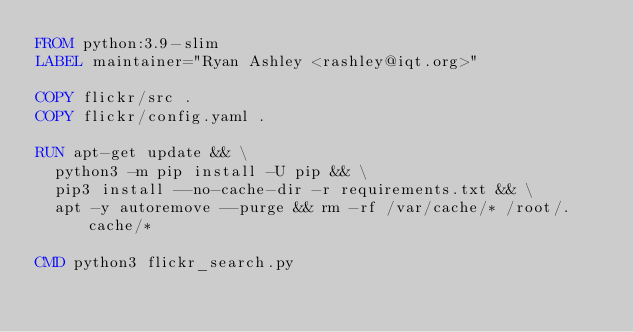<code> <loc_0><loc_0><loc_500><loc_500><_Dockerfile_>FROM python:3.9-slim
LABEL maintainer="Ryan Ashley <rashley@iqt.org>"

COPY flickr/src .
COPY flickr/config.yaml .

RUN apt-get update && \
  python3 -m pip install -U pip && \
  pip3 install --no-cache-dir -r requirements.txt && \
  apt -y autoremove --purge && rm -rf /var/cache/* /root/.cache/*

CMD python3 flickr_search.py
</code> 